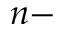<formula> <loc_0><loc_0><loc_500><loc_500>n -</formula> 